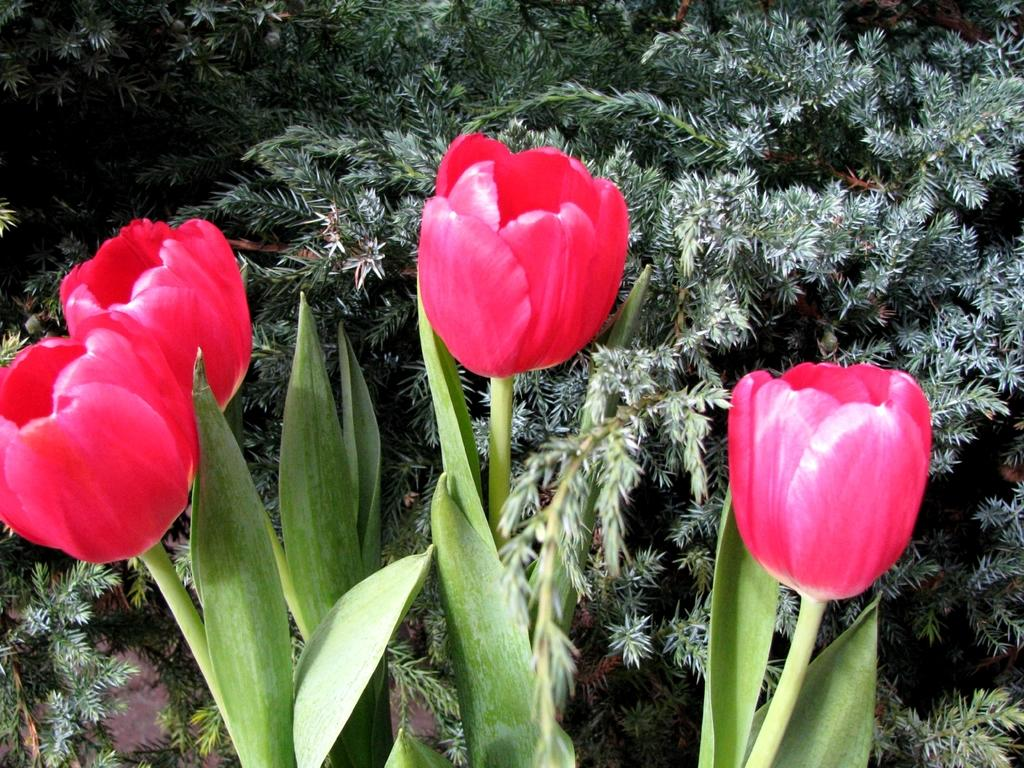What can be seen in the foreground of the picture? There are flowers and leaves in the foreground of the picture. What else is visible in the foreground besides the flowers and leaves? There is no additional information provided about the foreground, so we cannot answer this question definitively. What type of vegetation can be seen at the top of the picture? There are plants visible at the top of the picture. What statement does the father make about the list in the image? There is no father or list present in the image, so this question cannot be answered definitively. 